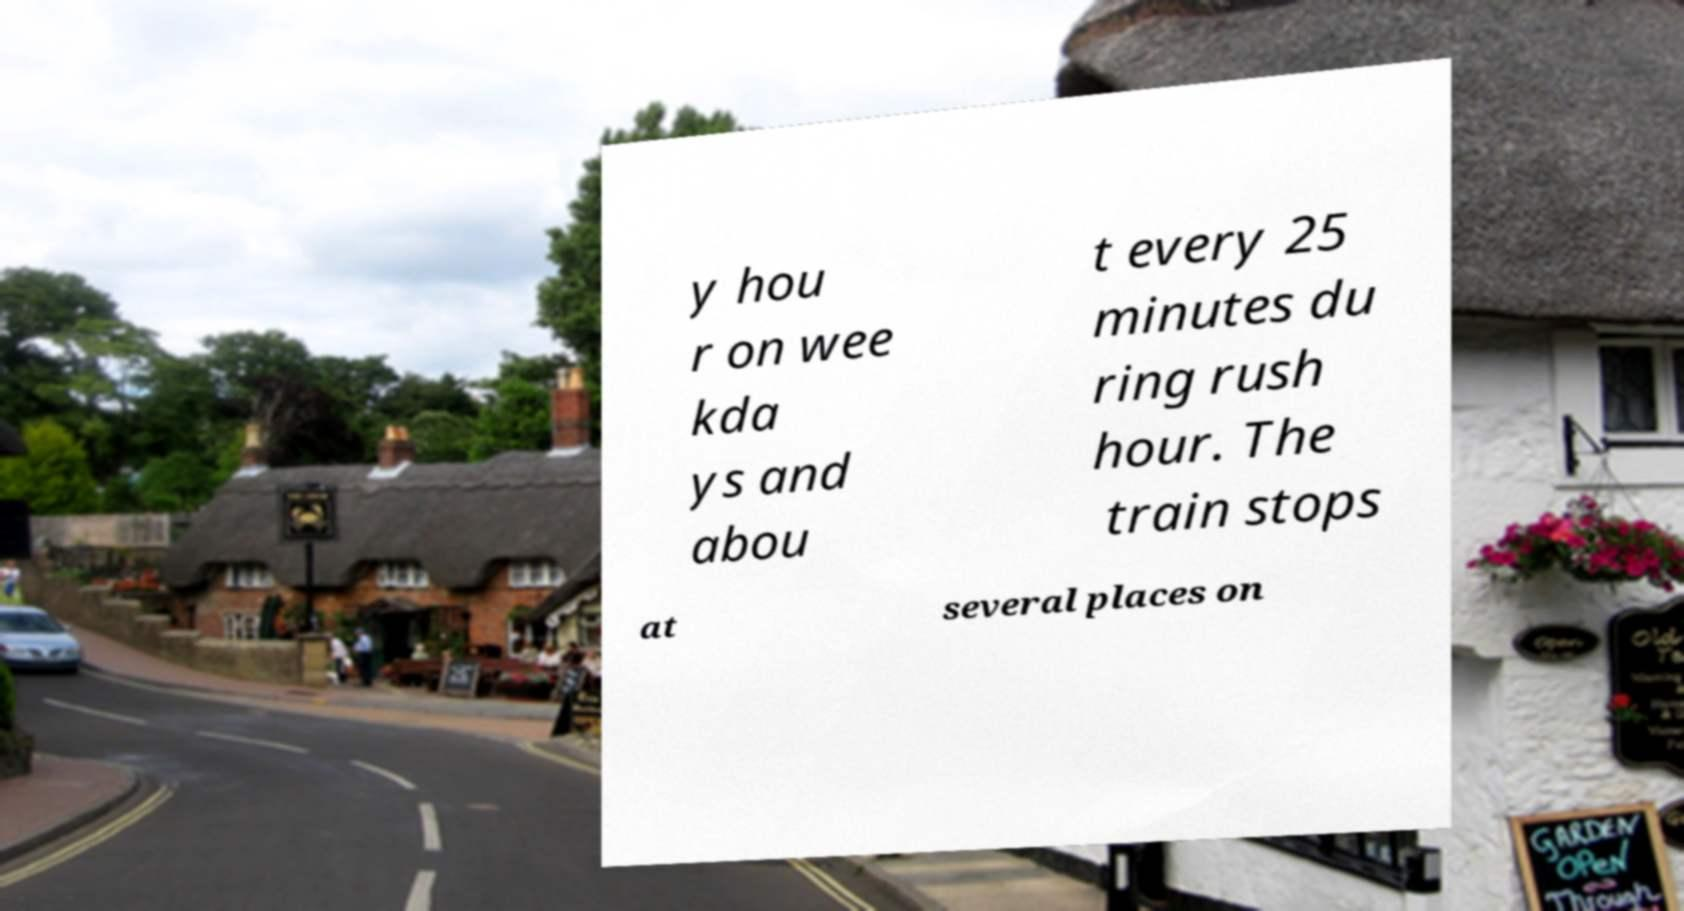What messages or text are displayed in this image? I need them in a readable, typed format. y hou r on wee kda ys and abou t every 25 minutes du ring rush hour. The train stops at several places on 